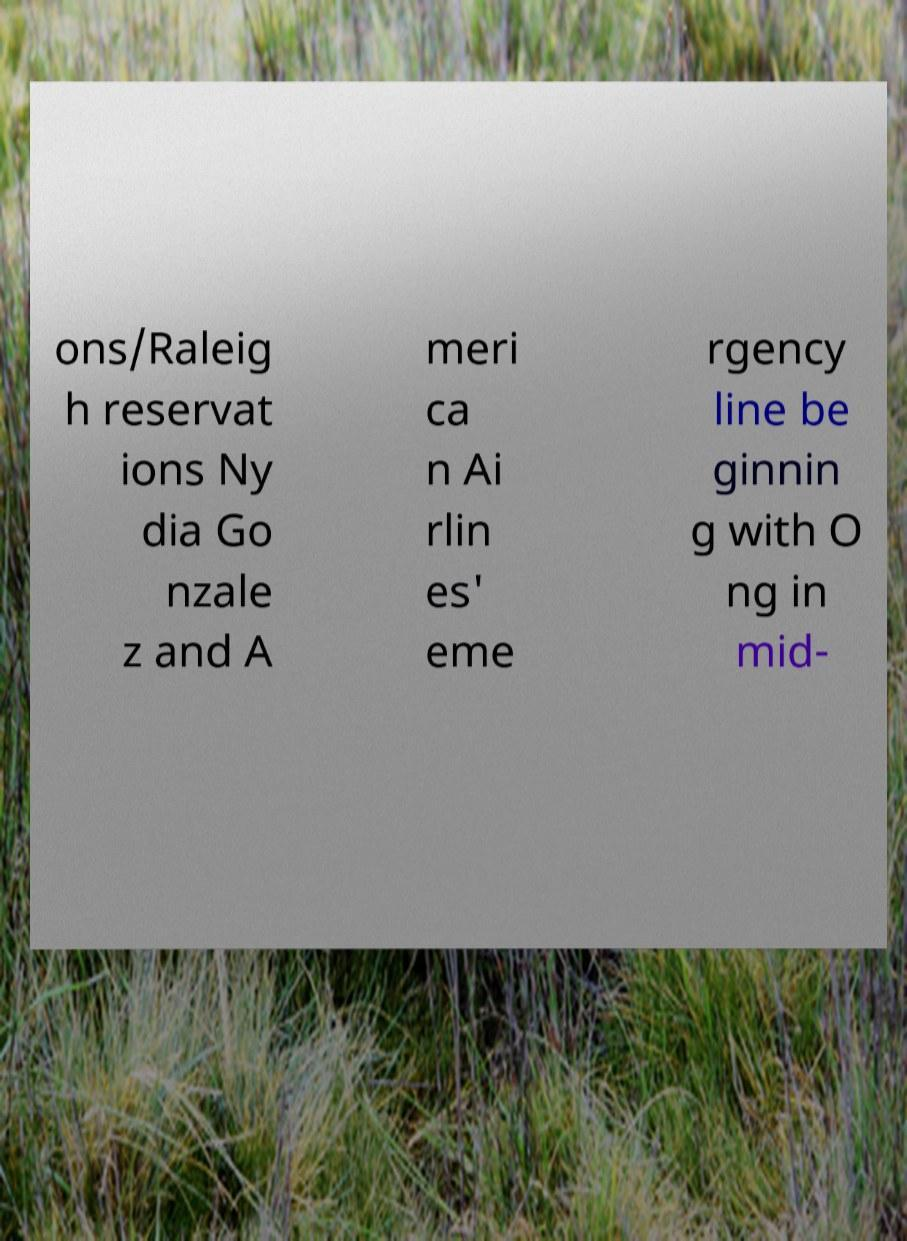For documentation purposes, I need the text within this image transcribed. Could you provide that? ons/Raleig h reservat ions Ny dia Go nzale z and A meri ca n Ai rlin es' eme rgency line be ginnin g with O ng in mid- 